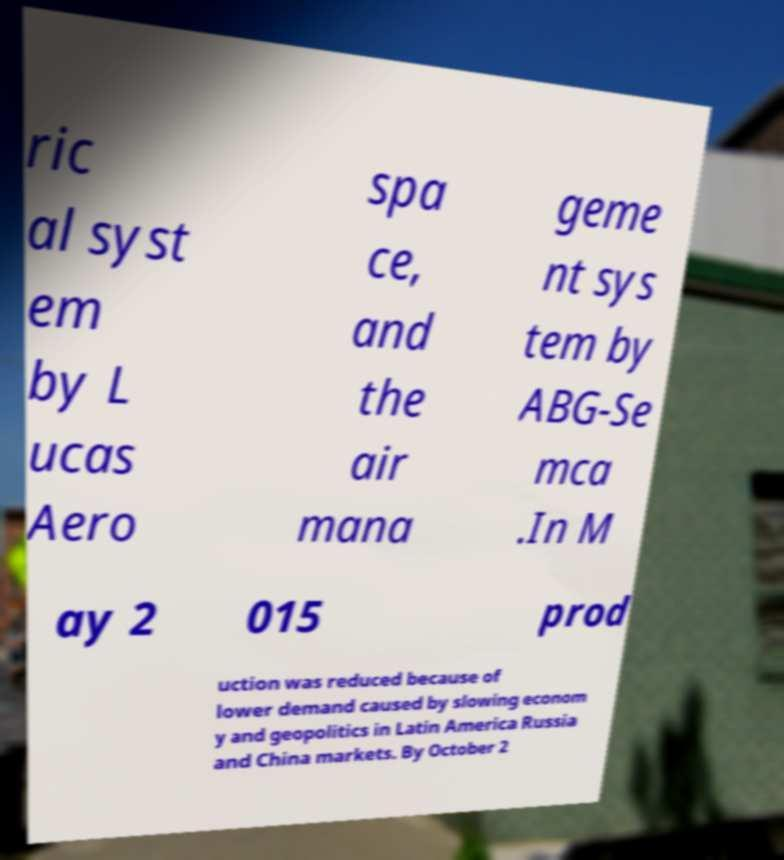Please identify and transcribe the text found in this image. ric al syst em by L ucas Aero spa ce, and the air mana geme nt sys tem by ABG-Se mca .In M ay 2 015 prod uction was reduced because of lower demand caused by slowing econom y and geopolitics in Latin America Russia and China markets. By October 2 